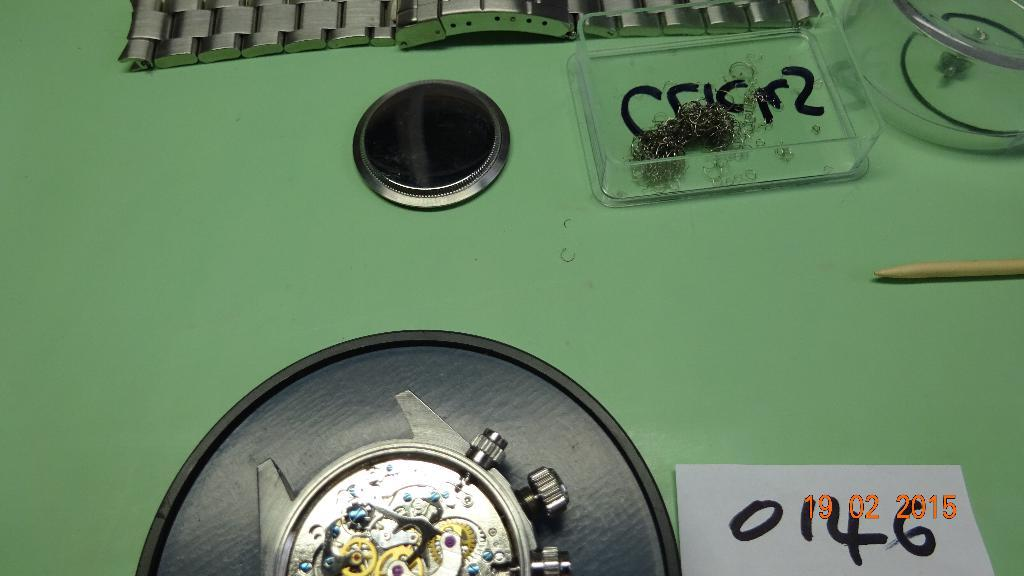What type of object can be seen in the image? There is a wrist watch in the image. What else is present in the image besides the wrist watch? There is a paper note in the image. Can you describe any other objects in the image? There are other objects in the image, but their specific details are not mentioned in the provided facts. What type of apparel is the wrist watch paired with in the image? The provided facts do not mention any apparel in the image, so it cannot be determined which type of clothing the wrist watch might be paired with. 